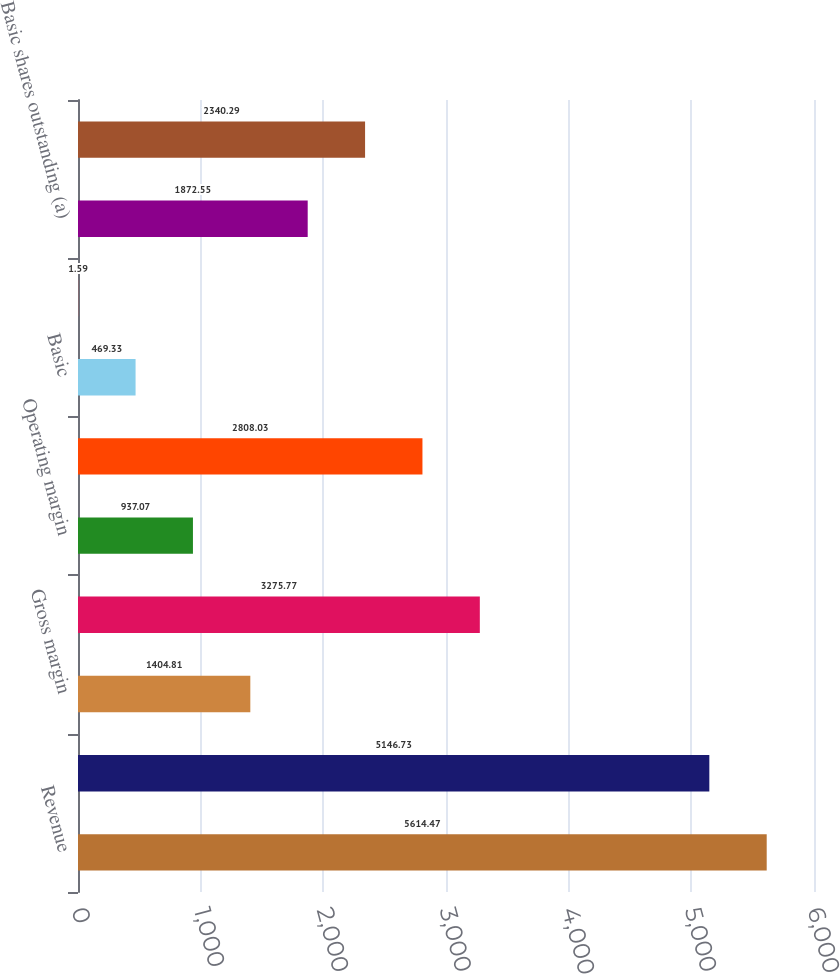<chart> <loc_0><loc_0><loc_500><loc_500><bar_chart><fcel>Revenue<fcel>Gross profit<fcel>Gross margin<fcel>Operating income<fcel>Operating margin<fcel>Net income<fcel>Basic<fcel>Diluted<fcel>Basic shares outstanding (a)<fcel>Diluted shares outstanding (a)<nl><fcel>5614.47<fcel>5146.73<fcel>1404.81<fcel>3275.77<fcel>937.07<fcel>2808.03<fcel>469.33<fcel>1.59<fcel>1872.55<fcel>2340.29<nl></chart> 